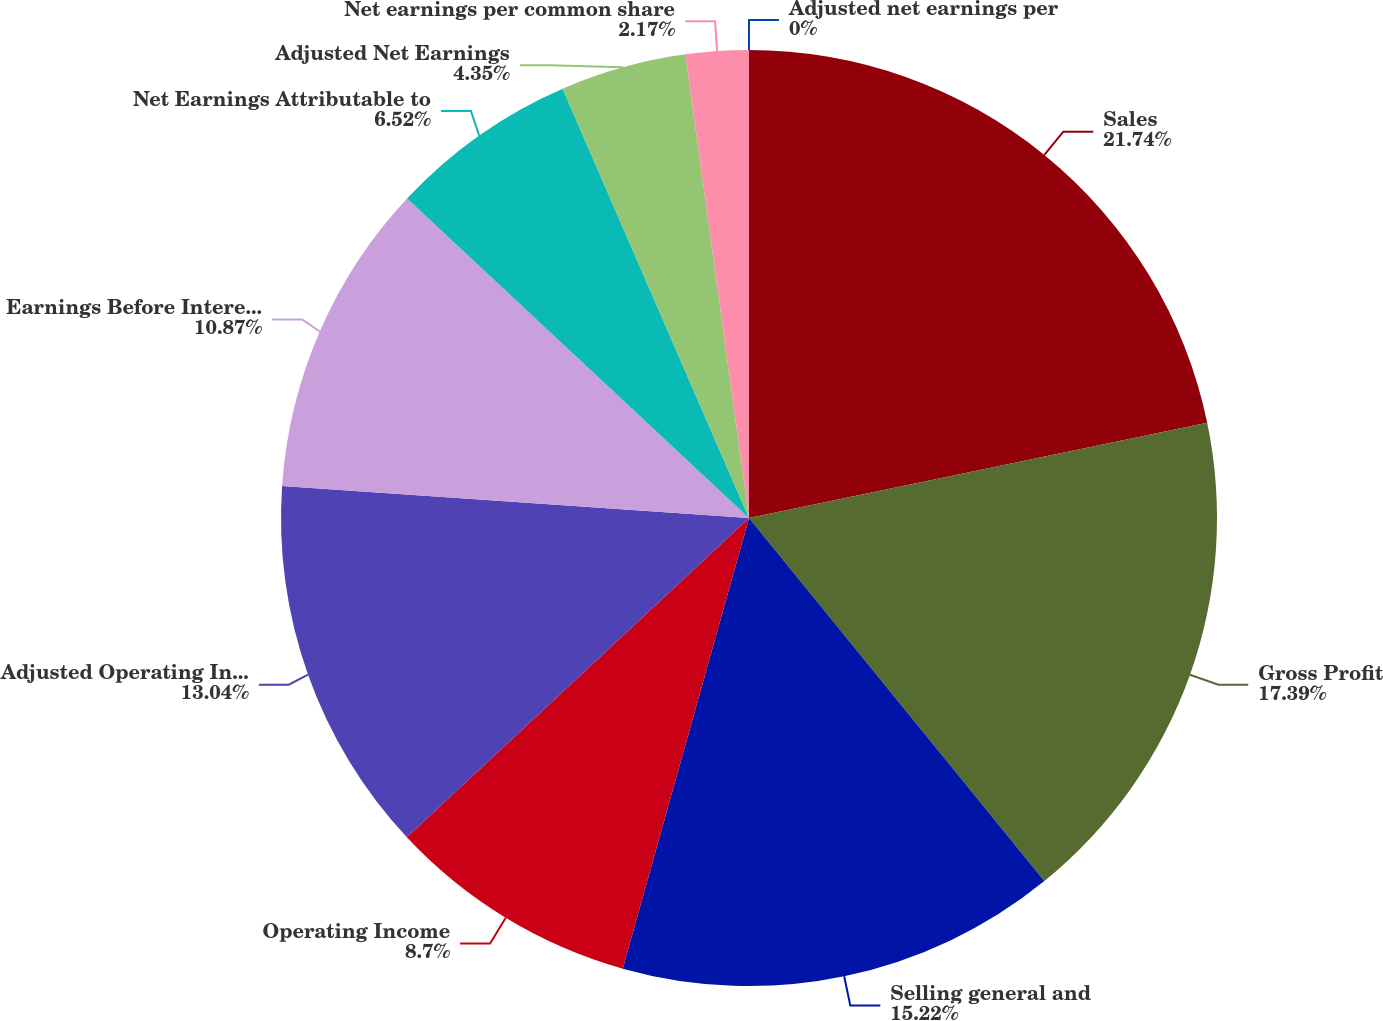Convert chart to OTSL. <chart><loc_0><loc_0><loc_500><loc_500><pie_chart><fcel>Sales<fcel>Gross Profit<fcel>Selling general and<fcel>Operating Income<fcel>Adjusted Operating Income<fcel>Earnings Before Interest and<fcel>Net Earnings Attributable to<fcel>Adjusted Net Earnings<fcel>Net earnings per common share<fcel>Adjusted net earnings per<nl><fcel>21.74%<fcel>17.39%<fcel>15.22%<fcel>8.7%<fcel>13.04%<fcel>10.87%<fcel>6.52%<fcel>4.35%<fcel>2.17%<fcel>0.0%<nl></chart> 